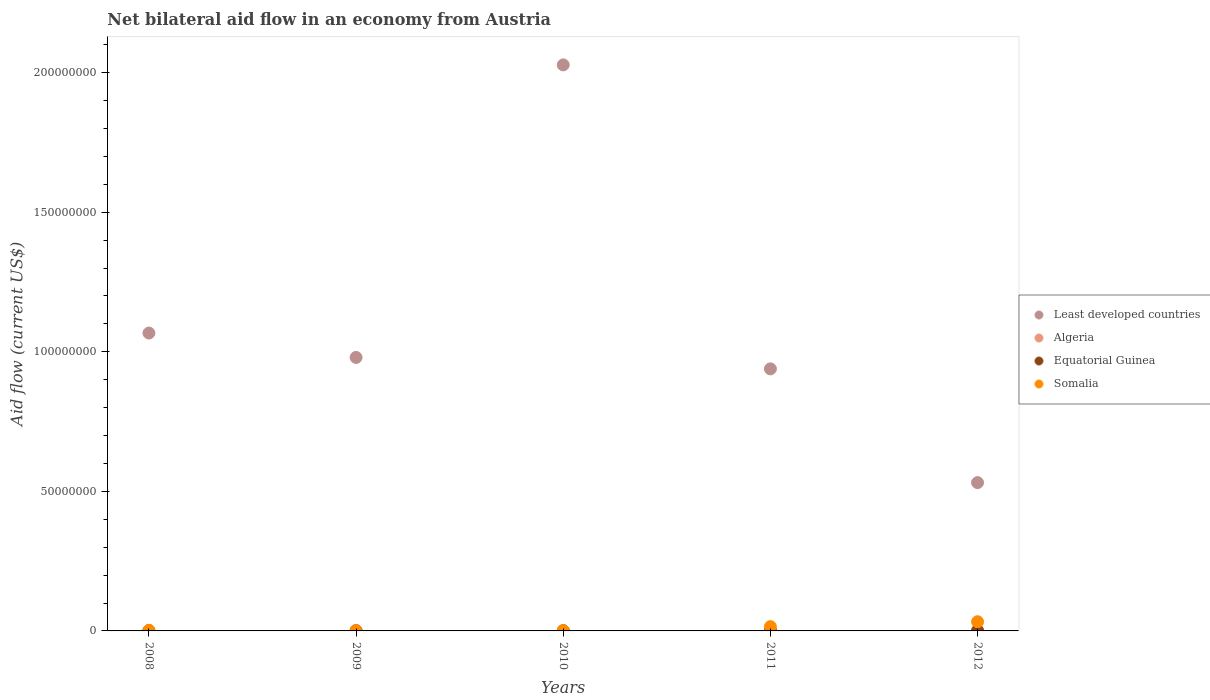How many different coloured dotlines are there?
Give a very brief answer. 4. Is the number of dotlines equal to the number of legend labels?
Provide a short and direct response. Yes. What is the net bilateral aid flow in Algeria in 2008?
Your answer should be very brief. 1.70e+05. Across all years, what is the maximum net bilateral aid flow in Somalia?
Provide a succinct answer. 3.29e+06. Across all years, what is the minimum net bilateral aid flow in Somalia?
Provide a succinct answer. 9.00e+04. What is the difference between the net bilateral aid flow in Algeria in 2009 and that in 2012?
Give a very brief answer. -1.10e+05. What is the difference between the net bilateral aid flow in Somalia in 2009 and the net bilateral aid flow in Least developed countries in 2010?
Give a very brief answer. -2.03e+08. What is the average net bilateral aid flow in Equatorial Guinea per year?
Provide a succinct answer. 1.20e+04. In the year 2008, what is the difference between the net bilateral aid flow in Least developed countries and net bilateral aid flow in Equatorial Guinea?
Provide a succinct answer. 1.07e+08. What is the ratio of the net bilateral aid flow in Equatorial Guinea in 2009 to that in 2012?
Offer a terse response. 0.5. In how many years, is the net bilateral aid flow in Algeria greater than the average net bilateral aid flow in Algeria taken over all years?
Your answer should be very brief. 2. Is it the case that in every year, the sum of the net bilateral aid flow in Least developed countries and net bilateral aid flow in Algeria  is greater than the net bilateral aid flow in Equatorial Guinea?
Make the answer very short. Yes. Does the net bilateral aid flow in Somalia monotonically increase over the years?
Provide a short and direct response. No. Is the net bilateral aid flow in Algeria strictly greater than the net bilateral aid flow in Least developed countries over the years?
Give a very brief answer. No. Is the net bilateral aid flow in Algeria strictly less than the net bilateral aid flow in Least developed countries over the years?
Give a very brief answer. Yes. How many dotlines are there?
Your response must be concise. 4. Are the values on the major ticks of Y-axis written in scientific E-notation?
Keep it short and to the point. No. Does the graph contain any zero values?
Ensure brevity in your answer.  No. Does the graph contain grids?
Provide a succinct answer. No. Where does the legend appear in the graph?
Give a very brief answer. Center right. How are the legend labels stacked?
Provide a succinct answer. Vertical. What is the title of the graph?
Give a very brief answer. Net bilateral aid flow in an economy from Austria. What is the label or title of the Y-axis?
Ensure brevity in your answer.  Aid flow (current US$). What is the Aid flow (current US$) in Least developed countries in 2008?
Provide a short and direct response. 1.07e+08. What is the Aid flow (current US$) of Algeria in 2008?
Provide a short and direct response. 1.70e+05. What is the Aid flow (current US$) in Equatorial Guinea in 2008?
Provide a succinct answer. 10000. What is the Aid flow (current US$) of Least developed countries in 2009?
Offer a terse response. 9.80e+07. What is the Aid flow (current US$) of Algeria in 2009?
Your response must be concise. 1.40e+05. What is the Aid flow (current US$) of Least developed countries in 2010?
Provide a short and direct response. 2.03e+08. What is the Aid flow (current US$) of Equatorial Guinea in 2010?
Your response must be concise. 10000. What is the Aid flow (current US$) in Somalia in 2010?
Your response must be concise. 1.10e+05. What is the Aid flow (current US$) in Least developed countries in 2011?
Offer a very short reply. 9.39e+07. What is the Aid flow (current US$) of Algeria in 2011?
Your response must be concise. 1.50e+05. What is the Aid flow (current US$) of Equatorial Guinea in 2011?
Ensure brevity in your answer.  10000. What is the Aid flow (current US$) in Somalia in 2011?
Offer a very short reply. 1.54e+06. What is the Aid flow (current US$) of Least developed countries in 2012?
Ensure brevity in your answer.  5.31e+07. What is the Aid flow (current US$) of Algeria in 2012?
Your answer should be very brief. 2.50e+05. What is the Aid flow (current US$) of Equatorial Guinea in 2012?
Offer a terse response. 2.00e+04. What is the Aid flow (current US$) in Somalia in 2012?
Keep it short and to the point. 3.29e+06. Across all years, what is the maximum Aid flow (current US$) in Least developed countries?
Your answer should be compact. 2.03e+08. Across all years, what is the maximum Aid flow (current US$) in Algeria?
Provide a short and direct response. 2.50e+05. Across all years, what is the maximum Aid flow (current US$) of Equatorial Guinea?
Offer a very short reply. 2.00e+04. Across all years, what is the maximum Aid flow (current US$) in Somalia?
Give a very brief answer. 3.29e+06. Across all years, what is the minimum Aid flow (current US$) of Least developed countries?
Your answer should be compact. 5.31e+07. Across all years, what is the minimum Aid flow (current US$) in Algeria?
Make the answer very short. 1.20e+05. Across all years, what is the minimum Aid flow (current US$) of Somalia?
Make the answer very short. 9.00e+04. What is the total Aid flow (current US$) in Least developed countries in the graph?
Provide a short and direct response. 5.54e+08. What is the total Aid flow (current US$) in Algeria in the graph?
Offer a very short reply. 8.30e+05. What is the total Aid flow (current US$) in Somalia in the graph?
Your response must be concise. 5.25e+06. What is the difference between the Aid flow (current US$) of Least developed countries in 2008 and that in 2009?
Your answer should be compact. 8.74e+06. What is the difference between the Aid flow (current US$) of Equatorial Guinea in 2008 and that in 2009?
Give a very brief answer. 0. What is the difference between the Aid flow (current US$) of Somalia in 2008 and that in 2009?
Provide a short and direct response. 1.30e+05. What is the difference between the Aid flow (current US$) of Least developed countries in 2008 and that in 2010?
Provide a short and direct response. -9.61e+07. What is the difference between the Aid flow (current US$) in Equatorial Guinea in 2008 and that in 2010?
Make the answer very short. 0. What is the difference between the Aid flow (current US$) of Somalia in 2008 and that in 2010?
Provide a succinct answer. 1.10e+05. What is the difference between the Aid flow (current US$) of Least developed countries in 2008 and that in 2011?
Provide a succinct answer. 1.28e+07. What is the difference between the Aid flow (current US$) of Algeria in 2008 and that in 2011?
Offer a terse response. 2.00e+04. What is the difference between the Aid flow (current US$) in Equatorial Guinea in 2008 and that in 2011?
Your answer should be compact. 0. What is the difference between the Aid flow (current US$) in Somalia in 2008 and that in 2011?
Your answer should be very brief. -1.32e+06. What is the difference between the Aid flow (current US$) of Least developed countries in 2008 and that in 2012?
Ensure brevity in your answer.  5.36e+07. What is the difference between the Aid flow (current US$) in Algeria in 2008 and that in 2012?
Your response must be concise. -8.00e+04. What is the difference between the Aid flow (current US$) of Equatorial Guinea in 2008 and that in 2012?
Your answer should be compact. -10000. What is the difference between the Aid flow (current US$) in Somalia in 2008 and that in 2012?
Ensure brevity in your answer.  -3.07e+06. What is the difference between the Aid flow (current US$) of Least developed countries in 2009 and that in 2010?
Offer a very short reply. -1.05e+08. What is the difference between the Aid flow (current US$) of Equatorial Guinea in 2009 and that in 2010?
Provide a short and direct response. 0. What is the difference between the Aid flow (current US$) in Least developed countries in 2009 and that in 2011?
Make the answer very short. 4.09e+06. What is the difference between the Aid flow (current US$) in Algeria in 2009 and that in 2011?
Keep it short and to the point. -10000. What is the difference between the Aid flow (current US$) in Equatorial Guinea in 2009 and that in 2011?
Your response must be concise. 0. What is the difference between the Aid flow (current US$) in Somalia in 2009 and that in 2011?
Offer a terse response. -1.45e+06. What is the difference between the Aid flow (current US$) in Least developed countries in 2009 and that in 2012?
Your answer should be very brief. 4.48e+07. What is the difference between the Aid flow (current US$) in Algeria in 2009 and that in 2012?
Make the answer very short. -1.10e+05. What is the difference between the Aid flow (current US$) of Equatorial Guinea in 2009 and that in 2012?
Your answer should be compact. -10000. What is the difference between the Aid flow (current US$) of Somalia in 2009 and that in 2012?
Your response must be concise. -3.20e+06. What is the difference between the Aid flow (current US$) of Least developed countries in 2010 and that in 2011?
Keep it short and to the point. 1.09e+08. What is the difference between the Aid flow (current US$) in Equatorial Guinea in 2010 and that in 2011?
Offer a terse response. 0. What is the difference between the Aid flow (current US$) of Somalia in 2010 and that in 2011?
Give a very brief answer. -1.43e+06. What is the difference between the Aid flow (current US$) of Least developed countries in 2010 and that in 2012?
Ensure brevity in your answer.  1.50e+08. What is the difference between the Aid flow (current US$) in Algeria in 2010 and that in 2012?
Your answer should be compact. -1.30e+05. What is the difference between the Aid flow (current US$) of Equatorial Guinea in 2010 and that in 2012?
Your answer should be very brief. -10000. What is the difference between the Aid flow (current US$) in Somalia in 2010 and that in 2012?
Ensure brevity in your answer.  -3.18e+06. What is the difference between the Aid flow (current US$) of Least developed countries in 2011 and that in 2012?
Provide a succinct answer. 4.08e+07. What is the difference between the Aid flow (current US$) of Algeria in 2011 and that in 2012?
Make the answer very short. -1.00e+05. What is the difference between the Aid flow (current US$) of Equatorial Guinea in 2011 and that in 2012?
Offer a terse response. -10000. What is the difference between the Aid flow (current US$) in Somalia in 2011 and that in 2012?
Offer a terse response. -1.75e+06. What is the difference between the Aid flow (current US$) of Least developed countries in 2008 and the Aid flow (current US$) of Algeria in 2009?
Provide a succinct answer. 1.07e+08. What is the difference between the Aid flow (current US$) of Least developed countries in 2008 and the Aid flow (current US$) of Equatorial Guinea in 2009?
Your response must be concise. 1.07e+08. What is the difference between the Aid flow (current US$) in Least developed countries in 2008 and the Aid flow (current US$) in Somalia in 2009?
Keep it short and to the point. 1.07e+08. What is the difference between the Aid flow (current US$) of Equatorial Guinea in 2008 and the Aid flow (current US$) of Somalia in 2009?
Give a very brief answer. -8.00e+04. What is the difference between the Aid flow (current US$) of Least developed countries in 2008 and the Aid flow (current US$) of Algeria in 2010?
Give a very brief answer. 1.07e+08. What is the difference between the Aid flow (current US$) of Least developed countries in 2008 and the Aid flow (current US$) of Equatorial Guinea in 2010?
Offer a terse response. 1.07e+08. What is the difference between the Aid flow (current US$) of Least developed countries in 2008 and the Aid flow (current US$) of Somalia in 2010?
Your answer should be compact. 1.07e+08. What is the difference between the Aid flow (current US$) in Algeria in 2008 and the Aid flow (current US$) in Equatorial Guinea in 2010?
Your answer should be compact. 1.60e+05. What is the difference between the Aid flow (current US$) of Algeria in 2008 and the Aid flow (current US$) of Somalia in 2010?
Provide a succinct answer. 6.00e+04. What is the difference between the Aid flow (current US$) in Least developed countries in 2008 and the Aid flow (current US$) in Algeria in 2011?
Offer a very short reply. 1.07e+08. What is the difference between the Aid flow (current US$) in Least developed countries in 2008 and the Aid flow (current US$) in Equatorial Guinea in 2011?
Your answer should be very brief. 1.07e+08. What is the difference between the Aid flow (current US$) of Least developed countries in 2008 and the Aid flow (current US$) of Somalia in 2011?
Your answer should be compact. 1.05e+08. What is the difference between the Aid flow (current US$) of Algeria in 2008 and the Aid flow (current US$) of Equatorial Guinea in 2011?
Provide a succinct answer. 1.60e+05. What is the difference between the Aid flow (current US$) of Algeria in 2008 and the Aid flow (current US$) of Somalia in 2011?
Give a very brief answer. -1.37e+06. What is the difference between the Aid flow (current US$) of Equatorial Guinea in 2008 and the Aid flow (current US$) of Somalia in 2011?
Make the answer very short. -1.53e+06. What is the difference between the Aid flow (current US$) of Least developed countries in 2008 and the Aid flow (current US$) of Algeria in 2012?
Provide a short and direct response. 1.06e+08. What is the difference between the Aid flow (current US$) of Least developed countries in 2008 and the Aid flow (current US$) of Equatorial Guinea in 2012?
Keep it short and to the point. 1.07e+08. What is the difference between the Aid flow (current US$) of Least developed countries in 2008 and the Aid flow (current US$) of Somalia in 2012?
Keep it short and to the point. 1.03e+08. What is the difference between the Aid flow (current US$) in Algeria in 2008 and the Aid flow (current US$) in Somalia in 2012?
Make the answer very short. -3.12e+06. What is the difference between the Aid flow (current US$) in Equatorial Guinea in 2008 and the Aid flow (current US$) in Somalia in 2012?
Keep it short and to the point. -3.28e+06. What is the difference between the Aid flow (current US$) in Least developed countries in 2009 and the Aid flow (current US$) in Algeria in 2010?
Your answer should be compact. 9.78e+07. What is the difference between the Aid flow (current US$) in Least developed countries in 2009 and the Aid flow (current US$) in Equatorial Guinea in 2010?
Your answer should be very brief. 9.80e+07. What is the difference between the Aid flow (current US$) of Least developed countries in 2009 and the Aid flow (current US$) of Somalia in 2010?
Your response must be concise. 9.78e+07. What is the difference between the Aid flow (current US$) of Equatorial Guinea in 2009 and the Aid flow (current US$) of Somalia in 2010?
Provide a short and direct response. -1.00e+05. What is the difference between the Aid flow (current US$) of Least developed countries in 2009 and the Aid flow (current US$) of Algeria in 2011?
Make the answer very short. 9.78e+07. What is the difference between the Aid flow (current US$) in Least developed countries in 2009 and the Aid flow (current US$) in Equatorial Guinea in 2011?
Ensure brevity in your answer.  9.80e+07. What is the difference between the Aid flow (current US$) in Least developed countries in 2009 and the Aid flow (current US$) in Somalia in 2011?
Your answer should be very brief. 9.64e+07. What is the difference between the Aid flow (current US$) of Algeria in 2009 and the Aid flow (current US$) of Somalia in 2011?
Offer a very short reply. -1.40e+06. What is the difference between the Aid flow (current US$) of Equatorial Guinea in 2009 and the Aid flow (current US$) of Somalia in 2011?
Provide a short and direct response. -1.53e+06. What is the difference between the Aid flow (current US$) of Least developed countries in 2009 and the Aid flow (current US$) of Algeria in 2012?
Your answer should be compact. 9.77e+07. What is the difference between the Aid flow (current US$) in Least developed countries in 2009 and the Aid flow (current US$) in Equatorial Guinea in 2012?
Your answer should be very brief. 9.79e+07. What is the difference between the Aid flow (current US$) of Least developed countries in 2009 and the Aid flow (current US$) of Somalia in 2012?
Keep it short and to the point. 9.47e+07. What is the difference between the Aid flow (current US$) of Algeria in 2009 and the Aid flow (current US$) of Equatorial Guinea in 2012?
Make the answer very short. 1.20e+05. What is the difference between the Aid flow (current US$) in Algeria in 2009 and the Aid flow (current US$) in Somalia in 2012?
Give a very brief answer. -3.15e+06. What is the difference between the Aid flow (current US$) of Equatorial Guinea in 2009 and the Aid flow (current US$) of Somalia in 2012?
Your response must be concise. -3.28e+06. What is the difference between the Aid flow (current US$) of Least developed countries in 2010 and the Aid flow (current US$) of Algeria in 2011?
Your response must be concise. 2.03e+08. What is the difference between the Aid flow (current US$) in Least developed countries in 2010 and the Aid flow (current US$) in Equatorial Guinea in 2011?
Your answer should be very brief. 2.03e+08. What is the difference between the Aid flow (current US$) of Least developed countries in 2010 and the Aid flow (current US$) of Somalia in 2011?
Provide a short and direct response. 2.01e+08. What is the difference between the Aid flow (current US$) in Algeria in 2010 and the Aid flow (current US$) in Equatorial Guinea in 2011?
Offer a terse response. 1.10e+05. What is the difference between the Aid flow (current US$) of Algeria in 2010 and the Aid flow (current US$) of Somalia in 2011?
Your answer should be very brief. -1.42e+06. What is the difference between the Aid flow (current US$) of Equatorial Guinea in 2010 and the Aid flow (current US$) of Somalia in 2011?
Give a very brief answer. -1.53e+06. What is the difference between the Aid flow (current US$) in Least developed countries in 2010 and the Aid flow (current US$) in Algeria in 2012?
Offer a very short reply. 2.03e+08. What is the difference between the Aid flow (current US$) of Least developed countries in 2010 and the Aid flow (current US$) of Equatorial Guinea in 2012?
Your answer should be very brief. 2.03e+08. What is the difference between the Aid flow (current US$) in Least developed countries in 2010 and the Aid flow (current US$) in Somalia in 2012?
Offer a very short reply. 1.99e+08. What is the difference between the Aid flow (current US$) in Algeria in 2010 and the Aid flow (current US$) in Equatorial Guinea in 2012?
Make the answer very short. 1.00e+05. What is the difference between the Aid flow (current US$) of Algeria in 2010 and the Aid flow (current US$) of Somalia in 2012?
Give a very brief answer. -3.17e+06. What is the difference between the Aid flow (current US$) of Equatorial Guinea in 2010 and the Aid flow (current US$) of Somalia in 2012?
Your answer should be compact. -3.28e+06. What is the difference between the Aid flow (current US$) of Least developed countries in 2011 and the Aid flow (current US$) of Algeria in 2012?
Keep it short and to the point. 9.36e+07. What is the difference between the Aid flow (current US$) in Least developed countries in 2011 and the Aid flow (current US$) in Equatorial Guinea in 2012?
Make the answer very short. 9.38e+07. What is the difference between the Aid flow (current US$) of Least developed countries in 2011 and the Aid flow (current US$) of Somalia in 2012?
Your answer should be very brief. 9.06e+07. What is the difference between the Aid flow (current US$) of Algeria in 2011 and the Aid flow (current US$) of Equatorial Guinea in 2012?
Offer a very short reply. 1.30e+05. What is the difference between the Aid flow (current US$) of Algeria in 2011 and the Aid flow (current US$) of Somalia in 2012?
Provide a short and direct response. -3.14e+06. What is the difference between the Aid flow (current US$) in Equatorial Guinea in 2011 and the Aid flow (current US$) in Somalia in 2012?
Your response must be concise. -3.28e+06. What is the average Aid flow (current US$) in Least developed countries per year?
Your answer should be compact. 1.11e+08. What is the average Aid flow (current US$) in Algeria per year?
Your answer should be very brief. 1.66e+05. What is the average Aid flow (current US$) of Equatorial Guinea per year?
Offer a terse response. 1.20e+04. What is the average Aid flow (current US$) of Somalia per year?
Provide a succinct answer. 1.05e+06. In the year 2008, what is the difference between the Aid flow (current US$) of Least developed countries and Aid flow (current US$) of Algeria?
Your answer should be very brief. 1.07e+08. In the year 2008, what is the difference between the Aid flow (current US$) in Least developed countries and Aid flow (current US$) in Equatorial Guinea?
Ensure brevity in your answer.  1.07e+08. In the year 2008, what is the difference between the Aid flow (current US$) in Least developed countries and Aid flow (current US$) in Somalia?
Provide a short and direct response. 1.06e+08. In the year 2008, what is the difference between the Aid flow (current US$) of Algeria and Aid flow (current US$) of Equatorial Guinea?
Your answer should be compact. 1.60e+05. In the year 2009, what is the difference between the Aid flow (current US$) of Least developed countries and Aid flow (current US$) of Algeria?
Ensure brevity in your answer.  9.78e+07. In the year 2009, what is the difference between the Aid flow (current US$) of Least developed countries and Aid flow (current US$) of Equatorial Guinea?
Your response must be concise. 9.80e+07. In the year 2009, what is the difference between the Aid flow (current US$) in Least developed countries and Aid flow (current US$) in Somalia?
Your answer should be very brief. 9.79e+07. In the year 2010, what is the difference between the Aid flow (current US$) of Least developed countries and Aid flow (current US$) of Algeria?
Ensure brevity in your answer.  2.03e+08. In the year 2010, what is the difference between the Aid flow (current US$) of Least developed countries and Aid flow (current US$) of Equatorial Guinea?
Provide a succinct answer. 2.03e+08. In the year 2010, what is the difference between the Aid flow (current US$) of Least developed countries and Aid flow (current US$) of Somalia?
Offer a terse response. 2.03e+08. In the year 2010, what is the difference between the Aid flow (current US$) in Algeria and Aid flow (current US$) in Somalia?
Provide a succinct answer. 10000. In the year 2010, what is the difference between the Aid flow (current US$) in Equatorial Guinea and Aid flow (current US$) in Somalia?
Offer a very short reply. -1.00e+05. In the year 2011, what is the difference between the Aid flow (current US$) in Least developed countries and Aid flow (current US$) in Algeria?
Give a very brief answer. 9.37e+07. In the year 2011, what is the difference between the Aid flow (current US$) of Least developed countries and Aid flow (current US$) of Equatorial Guinea?
Provide a short and direct response. 9.39e+07. In the year 2011, what is the difference between the Aid flow (current US$) in Least developed countries and Aid flow (current US$) in Somalia?
Provide a succinct answer. 9.23e+07. In the year 2011, what is the difference between the Aid flow (current US$) in Algeria and Aid flow (current US$) in Somalia?
Offer a very short reply. -1.39e+06. In the year 2011, what is the difference between the Aid flow (current US$) in Equatorial Guinea and Aid flow (current US$) in Somalia?
Ensure brevity in your answer.  -1.53e+06. In the year 2012, what is the difference between the Aid flow (current US$) in Least developed countries and Aid flow (current US$) in Algeria?
Offer a terse response. 5.29e+07. In the year 2012, what is the difference between the Aid flow (current US$) of Least developed countries and Aid flow (current US$) of Equatorial Guinea?
Give a very brief answer. 5.31e+07. In the year 2012, what is the difference between the Aid flow (current US$) in Least developed countries and Aid flow (current US$) in Somalia?
Your response must be concise. 4.98e+07. In the year 2012, what is the difference between the Aid flow (current US$) of Algeria and Aid flow (current US$) of Somalia?
Offer a very short reply. -3.04e+06. In the year 2012, what is the difference between the Aid flow (current US$) in Equatorial Guinea and Aid flow (current US$) in Somalia?
Offer a terse response. -3.27e+06. What is the ratio of the Aid flow (current US$) in Least developed countries in 2008 to that in 2009?
Your answer should be very brief. 1.09. What is the ratio of the Aid flow (current US$) of Algeria in 2008 to that in 2009?
Provide a short and direct response. 1.21. What is the ratio of the Aid flow (current US$) in Equatorial Guinea in 2008 to that in 2009?
Your answer should be very brief. 1. What is the ratio of the Aid flow (current US$) in Somalia in 2008 to that in 2009?
Make the answer very short. 2.44. What is the ratio of the Aid flow (current US$) in Least developed countries in 2008 to that in 2010?
Offer a very short reply. 0.53. What is the ratio of the Aid flow (current US$) of Algeria in 2008 to that in 2010?
Give a very brief answer. 1.42. What is the ratio of the Aid flow (current US$) of Least developed countries in 2008 to that in 2011?
Keep it short and to the point. 1.14. What is the ratio of the Aid flow (current US$) of Algeria in 2008 to that in 2011?
Ensure brevity in your answer.  1.13. What is the ratio of the Aid flow (current US$) of Somalia in 2008 to that in 2011?
Offer a terse response. 0.14. What is the ratio of the Aid flow (current US$) of Least developed countries in 2008 to that in 2012?
Ensure brevity in your answer.  2.01. What is the ratio of the Aid flow (current US$) in Algeria in 2008 to that in 2012?
Provide a succinct answer. 0.68. What is the ratio of the Aid flow (current US$) of Somalia in 2008 to that in 2012?
Give a very brief answer. 0.07. What is the ratio of the Aid flow (current US$) in Least developed countries in 2009 to that in 2010?
Provide a succinct answer. 0.48. What is the ratio of the Aid flow (current US$) of Equatorial Guinea in 2009 to that in 2010?
Give a very brief answer. 1. What is the ratio of the Aid flow (current US$) of Somalia in 2009 to that in 2010?
Give a very brief answer. 0.82. What is the ratio of the Aid flow (current US$) in Least developed countries in 2009 to that in 2011?
Your answer should be very brief. 1.04. What is the ratio of the Aid flow (current US$) in Algeria in 2009 to that in 2011?
Your answer should be compact. 0.93. What is the ratio of the Aid flow (current US$) in Equatorial Guinea in 2009 to that in 2011?
Ensure brevity in your answer.  1. What is the ratio of the Aid flow (current US$) of Somalia in 2009 to that in 2011?
Your response must be concise. 0.06. What is the ratio of the Aid flow (current US$) of Least developed countries in 2009 to that in 2012?
Provide a succinct answer. 1.84. What is the ratio of the Aid flow (current US$) in Algeria in 2009 to that in 2012?
Offer a very short reply. 0.56. What is the ratio of the Aid flow (current US$) of Equatorial Guinea in 2009 to that in 2012?
Keep it short and to the point. 0.5. What is the ratio of the Aid flow (current US$) of Somalia in 2009 to that in 2012?
Your answer should be compact. 0.03. What is the ratio of the Aid flow (current US$) in Least developed countries in 2010 to that in 2011?
Offer a very short reply. 2.16. What is the ratio of the Aid flow (current US$) in Equatorial Guinea in 2010 to that in 2011?
Provide a short and direct response. 1. What is the ratio of the Aid flow (current US$) of Somalia in 2010 to that in 2011?
Your answer should be very brief. 0.07. What is the ratio of the Aid flow (current US$) in Least developed countries in 2010 to that in 2012?
Offer a very short reply. 3.82. What is the ratio of the Aid flow (current US$) of Algeria in 2010 to that in 2012?
Provide a succinct answer. 0.48. What is the ratio of the Aid flow (current US$) of Equatorial Guinea in 2010 to that in 2012?
Provide a short and direct response. 0.5. What is the ratio of the Aid flow (current US$) in Somalia in 2010 to that in 2012?
Provide a succinct answer. 0.03. What is the ratio of the Aid flow (current US$) in Least developed countries in 2011 to that in 2012?
Offer a terse response. 1.77. What is the ratio of the Aid flow (current US$) in Equatorial Guinea in 2011 to that in 2012?
Keep it short and to the point. 0.5. What is the ratio of the Aid flow (current US$) of Somalia in 2011 to that in 2012?
Your answer should be compact. 0.47. What is the difference between the highest and the second highest Aid flow (current US$) in Least developed countries?
Make the answer very short. 9.61e+07. What is the difference between the highest and the second highest Aid flow (current US$) of Algeria?
Make the answer very short. 8.00e+04. What is the difference between the highest and the second highest Aid flow (current US$) in Equatorial Guinea?
Provide a succinct answer. 10000. What is the difference between the highest and the second highest Aid flow (current US$) in Somalia?
Give a very brief answer. 1.75e+06. What is the difference between the highest and the lowest Aid flow (current US$) in Least developed countries?
Give a very brief answer. 1.50e+08. What is the difference between the highest and the lowest Aid flow (current US$) of Algeria?
Give a very brief answer. 1.30e+05. What is the difference between the highest and the lowest Aid flow (current US$) of Equatorial Guinea?
Offer a terse response. 10000. What is the difference between the highest and the lowest Aid flow (current US$) of Somalia?
Give a very brief answer. 3.20e+06. 